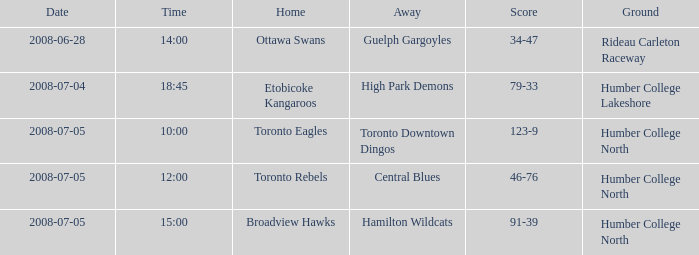What is the Away with a Time that is 14:00? Guelph Gargoyles. 